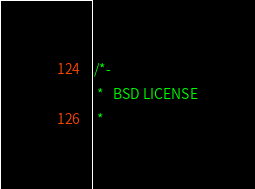<code> <loc_0><loc_0><loc_500><loc_500><_C_>/*-
 *   BSD LICENSE
 *</code> 